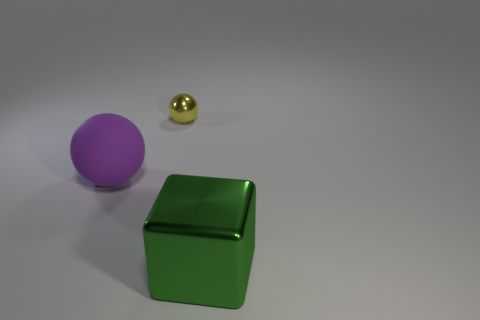What shape is the object that is both in front of the small yellow metallic sphere and behind the big green shiny block?
Give a very brief answer. Sphere. What color is the ball that is the same size as the green metallic block?
Provide a succinct answer. Purple. Are there any big rubber objects of the same color as the small ball?
Offer a terse response. No. Do the shiny object in front of the large purple thing and the sphere behind the big purple thing have the same size?
Offer a terse response. No. There is a thing that is both in front of the yellow shiny sphere and on the left side of the big shiny cube; what is its material?
Provide a succinct answer. Rubber. How many other things are the same size as the green cube?
Offer a terse response. 1. There is a thing in front of the purple rubber object; what is it made of?
Ensure brevity in your answer.  Metal. Does the small thing have the same shape as the large matte thing?
Your answer should be very brief. Yes. How many other objects are the same shape as the big green shiny object?
Make the answer very short. 0. What is the color of the big thing behind the large green metallic object?
Offer a terse response. Purple. 